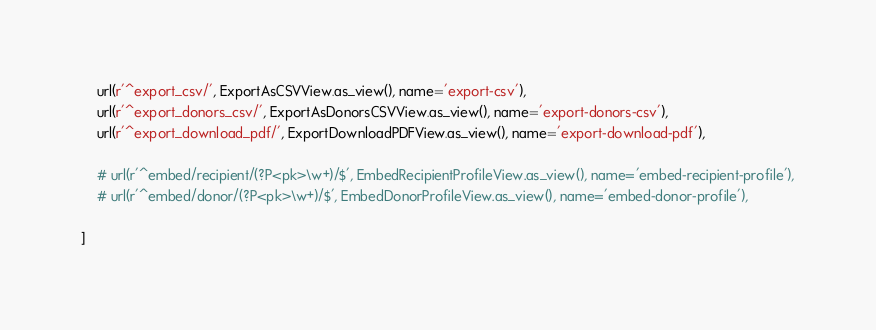<code> <loc_0><loc_0><loc_500><loc_500><_Python_>    url(r'^export_csv/', ExportAsCSVView.as_view(), name='export-csv'),
    url(r'^export_donors_csv/', ExportAsDonorsCSVView.as_view(), name='export-donors-csv'),
    url(r'^export_download_pdf/', ExportDownloadPDFView.as_view(), name='export-download-pdf'),

    # url(r'^embed/recipient/(?P<pk>\w+)/$', EmbedRecipientProfileView.as_view(), name='embed-recipient-profile'),
    # url(r'^embed/donor/(?P<pk>\w+)/$', EmbedDonorProfileView.as_view(), name='embed-donor-profile'),

]
</code> 